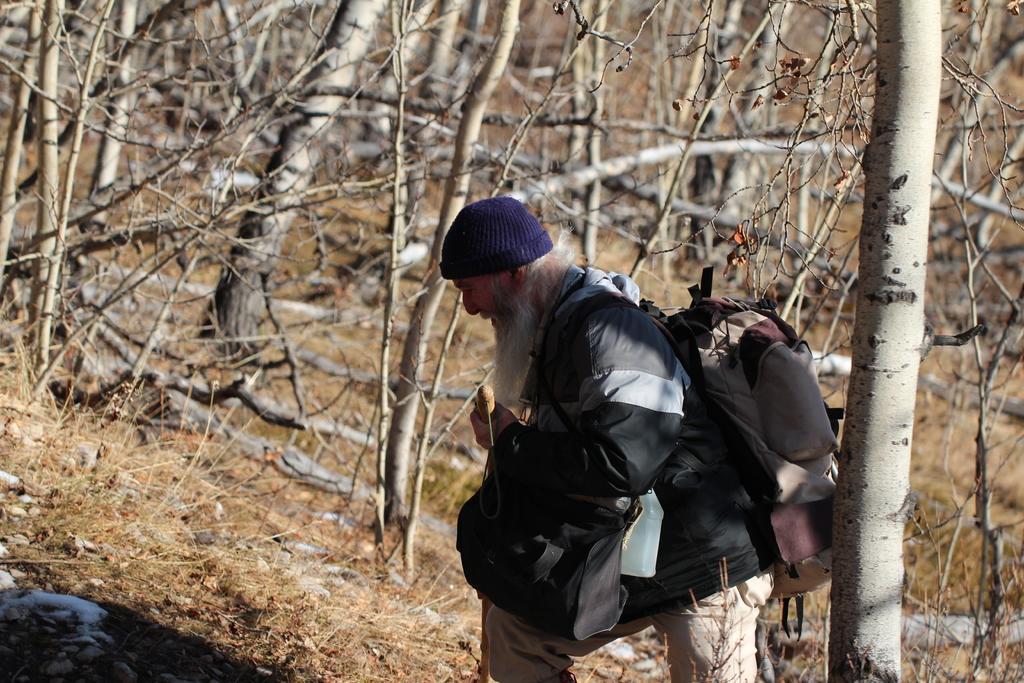Could you give a brief overview of what you see in this image? This picture might be taken from outside of the city and it is very sunny. In this picture, in the middle, we can see a man walking and he is also wearing a backpack. In the background, we can see some trees, at the bottom there is a land with some stones, grass and leaves. 